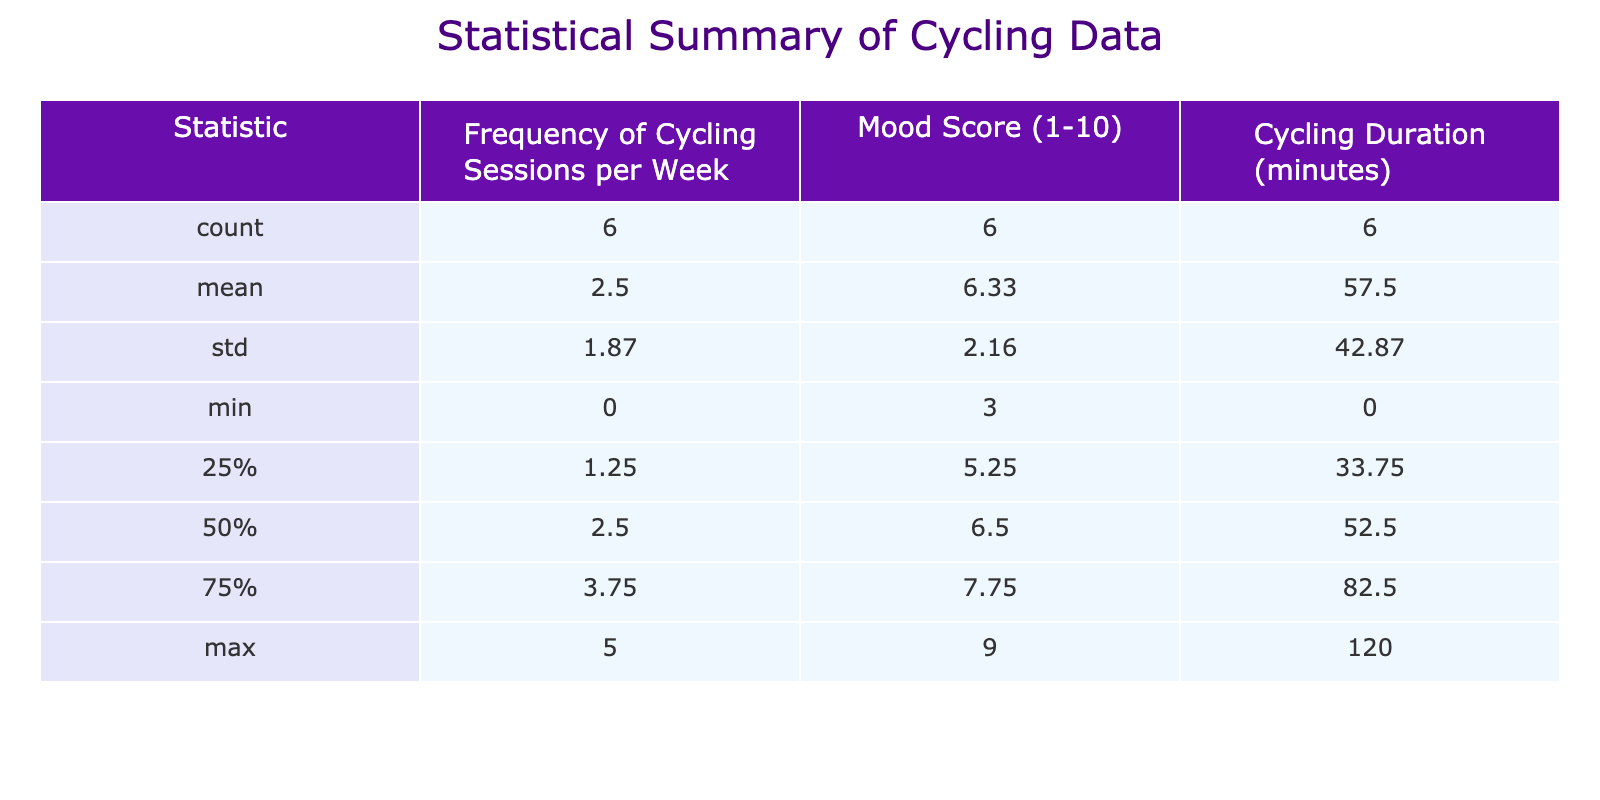What is the mood score for 3 cycling sessions per week? The table shows that the mood score associated with 3 cycling sessions per week is 7.
Answer: 7 What is the cycling duration for 5 sessions? According to the table, the cycling duration for 5 sessions per week is 120 minutes.
Answer: 120 minutes What is the average mood score for those who cycle more than 2 times a week? The mood scores for cycling more than 2 times a week are 6, 7, 8, and 9. Adding these gives 30, and since there are 4 sessions, the average is 30 divided by 4, which equals 7.5.
Answer: 7.5 Is the mood score higher for 4 sessions compared to 1 session? The mood score for 4 sessions is 8, while for 1 session it is 5. Since 8 is greater than 5, the statement is true.
Answer: Yes How does the mood score change with each additional cycling session? By observing the mood scores, we see they increase as the sessions go from 0 (3) to 5 (9). This shows a consistent increase of 1 to 2 points for each additional session, indicating a positive correlation between cycling frequency and mood.
Answer: Positive correlation What is the difference in mood score between those who cycle 2 times a week and those who cycle 4 times a week? The mood score for 2 sessions is 6, while for 4 sessions, it is 8. The difference is 8 minus 6, which equals 2.
Answer: 2 What is the maximum cycling duration recorded in the data? The table indicates that the maximum cycling duration is 120 minutes, associated with 5 cycling sessions per week.
Answer: 120 minutes What is the mood score for 0 cycling sessions? The mood score for 0 cycling sessions is 3, as stated in the table.
Answer: 3 What is the total cycling duration for someone who cycles between 1 and 3 times a week? The cycling durations for 1, 2, and 3 sessions are 30, 45, and 60 minutes respectively. Adding these gives 30 + 45 + 60 = 135 minutes.
Answer: 135 minutes 